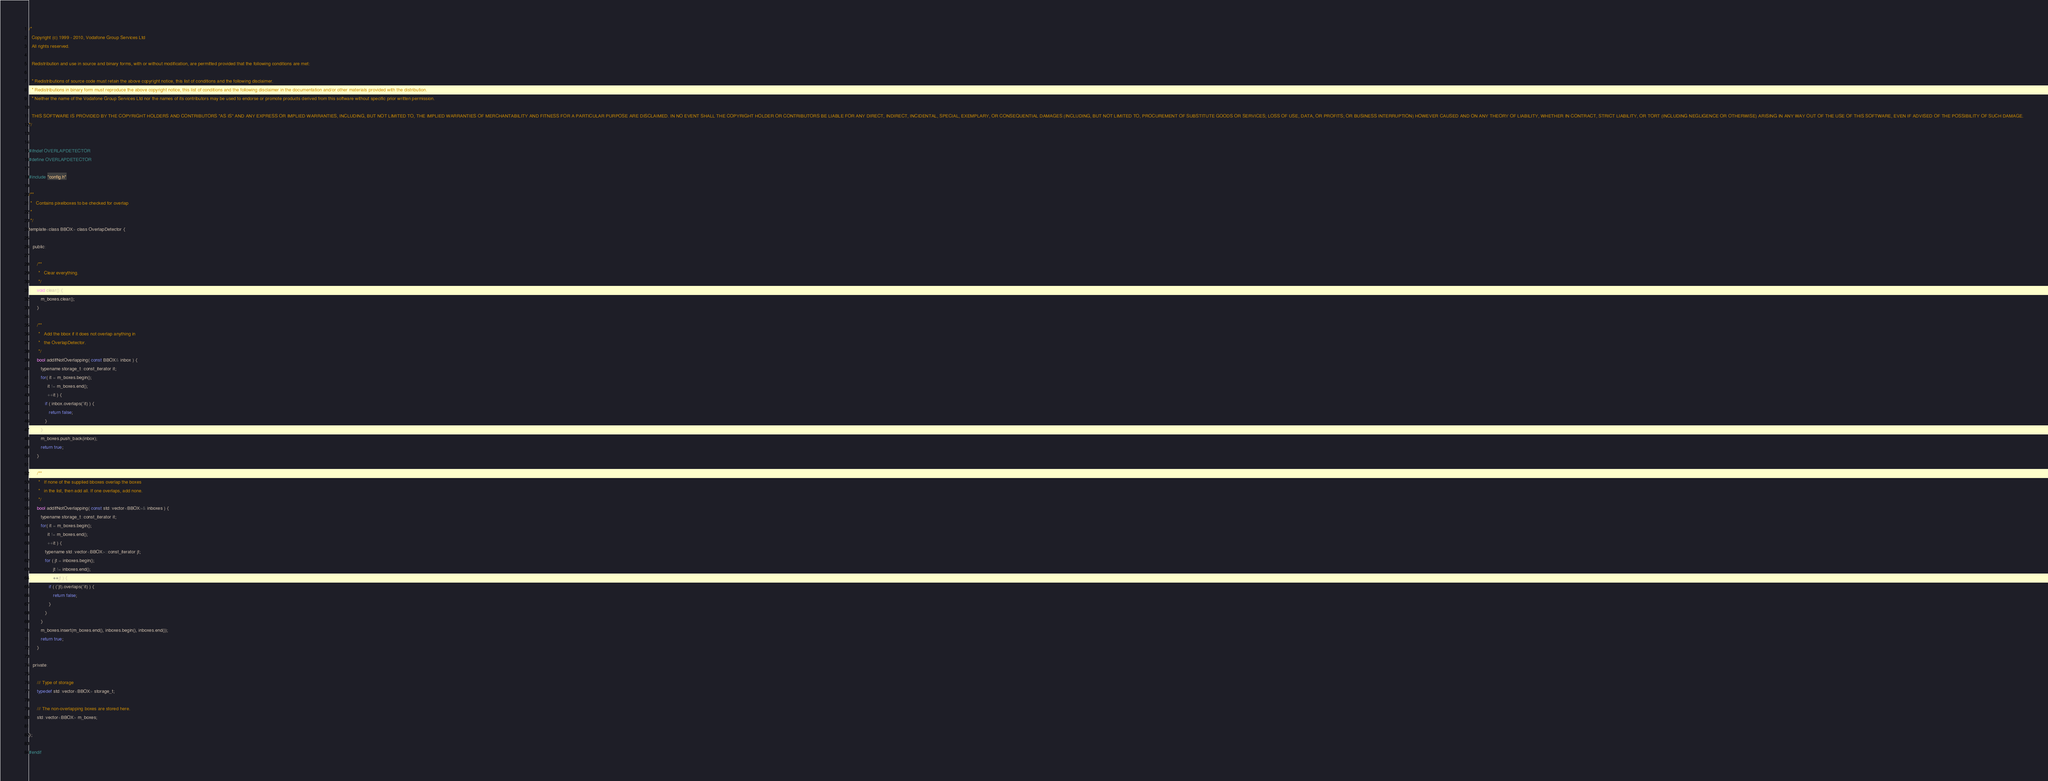<code> <loc_0><loc_0><loc_500><loc_500><_C_>/*
  Copyright (c) 1999 - 2010, Vodafone Group Services Ltd
  All rights reserved.

  Redistribution and use in source and binary forms, with or without modification, are permitted provided that the following conditions are met:

  * Redistributions of source code must retain the above copyright notice, this list of conditions and the following disclaimer.
  * Redistributions in binary form must reproduce the above copyright notice, this list of conditions and the following disclaimer in the documentation and/or other materials provided with the distribution.
  * Neither the name of the Vodafone Group Services Ltd nor the names of its contributors may be used to endorse or promote products derived from this software without specific prior written permission.

  THIS SOFTWARE IS PROVIDED BY THE COPYRIGHT HOLDERS AND CONTRIBUTORS "AS IS" AND ANY EXPRESS OR IMPLIED WARRANTIES, INCLUDING, BUT NOT LIMITED TO, THE IMPLIED WARRANTIES OF MERCHANTABILITY AND FITNESS FOR A PARTICULAR PURPOSE ARE DISCLAIMED. IN NO EVENT SHALL THE COPYRIGHT HOLDER OR CONTRIBUTORS BE LIABLE FOR ANY DIRECT, INDIRECT, INCIDENTAL, SPECIAL, EXEMPLARY, OR CONSEQUENTIAL DAMAGES (INCLUDING, BUT NOT LIMITED TO, PROCUREMENT OF SUBSTITUTE GOODS OR SERVICES; LOSS OF USE, DATA, OR PROFITS; OR BUSINESS INTERRUPTION) HOWEVER CAUSED AND ON ANY THEORY OF LIABILITY, WHETHER IN CONTRACT, STRICT LIABILITY, OR TORT (INCLUDING NEGLIGENCE OR OTHERWISE) ARISING IN ANY WAY OUT OF THE USE OF THIS SOFTWARE, EVEN IF ADVISED OF THE POSSIBILITY OF SUCH DAMAGE.
*/


#ifndef OVERLAPDETECTOR
#define OVERLAPDETECTOR

#include "config.h"

/**
 *   Contains pixelboxes to be checked for overlap
 *   
 */
template<class BBOX> class OverlapDetector {
   
   public:

      /**
       *   Clear everything.
       */
      void clear() {
         m_boxes.clear();
      }

      /**
       *   Add the bbox if it does not overlap anything in
       *   the OverlapDetector.
       */
      bool addIfNotOverlapping( const BBOX& inbox ) {
         typename storage_t::const_iterator it;
         for( it = m_boxes.begin();
              it != m_boxes.end();
              ++it ) {
            if ( inbox.overlaps(*it) ) {
               return false;
            }
         }
         m_boxes.push_back(inbox);
         return true;
      }

      /**
       *   If none of the supplied bboxes overlap the boxes
       *   in the list, then add all. If one overlaps, add none.
       */
      bool addIfNotOverlapping( const std::vector<BBOX>& inboxes ) {
         typename storage_t::const_iterator it;
         for( it = m_boxes.begin();
              it != m_boxes.end();
              ++it ) {
            typename std::vector<BBOX>::const_iterator jt;
            for ( jt = inboxes.begin();
                  jt != inboxes.end();
                  ++jt ) {
               if ( (*jt).overlaps(*it) ) {
                  return false;
               }
            }
         }
         m_boxes.insert(m_boxes.end(), inboxes.begin(), inboxes.end());
         return true;
      }

   private:

      /// Type of storage
      typedef std::vector<BBOX> storage_t;
   
      /// The non-overlapping boxes are stored here.
      std::vector<BBOX> m_boxes;
      
};

#endif
</code> 